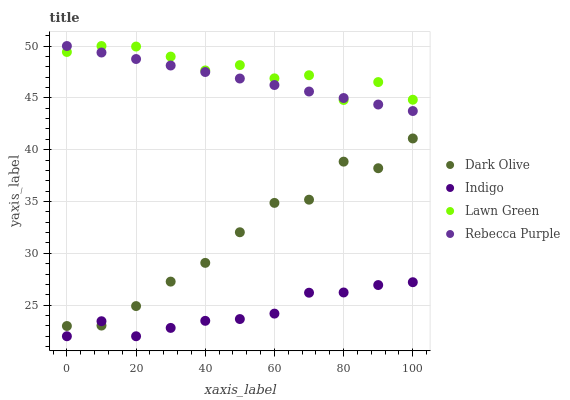Does Indigo have the minimum area under the curve?
Answer yes or no. Yes. Does Lawn Green have the maximum area under the curve?
Answer yes or no. Yes. Does Dark Olive have the minimum area under the curve?
Answer yes or no. No. Does Dark Olive have the maximum area under the curve?
Answer yes or no. No. Is Rebecca Purple the smoothest?
Answer yes or no. Yes. Is Dark Olive the roughest?
Answer yes or no. Yes. Is Indigo the smoothest?
Answer yes or no. No. Is Indigo the roughest?
Answer yes or no. No. Does Indigo have the lowest value?
Answer yes or no. Yes. Does Dark Olive have the lowest value?
Answer yes or no. No. Does Rebecca Purple have the highest value?
Answer yes or no. Yes. Does Dark Olive have the highest value?
Answer yes or no. No. Is Indigo less than Rebecca Purple?
Answer yes or no. Yes. Is Rebecca Purple greater than Dark Olive?
Answer yes or no. Yes. Does Lawn Green intersect Rebecca Purple?
Answer yes or no. Yes. Is Lawn Green less than Rebecca Purple?
Answer yes or no. No. Is Lawn Green greater than Rebecca Purple?
Answer yes or no. No. Does Indigo intersect Rebecca Purple?
Answer yes or no. No. 